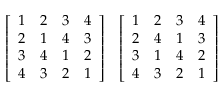<formula> <loc_0><loc_0><loc_500><loc_500>{ \left [ \begin{array} { l l l l } { 1 } & { 2 } & { 3 } & { 4 } \\ { 2 } & { 1 } & { 4 } & { 3 } \\ { 3 } & { 4 } & { 1 } & { 2 } \\ { 4 } & { 3 } & { 2 } & { 1 } \end{array} \right ] } \quad \left [ \begin{array} { l l l l } { 1 } & { 2 } & { 3 } & { 4 } \\ { 2 } & { 4 } & { 1 } & { 3 } \\ { 3 } & { 1 } & { 4 } & { 2 } \\ { 4 } & { 3 } & { 2 } & { 1 } \end{array} \right ]</formula> 